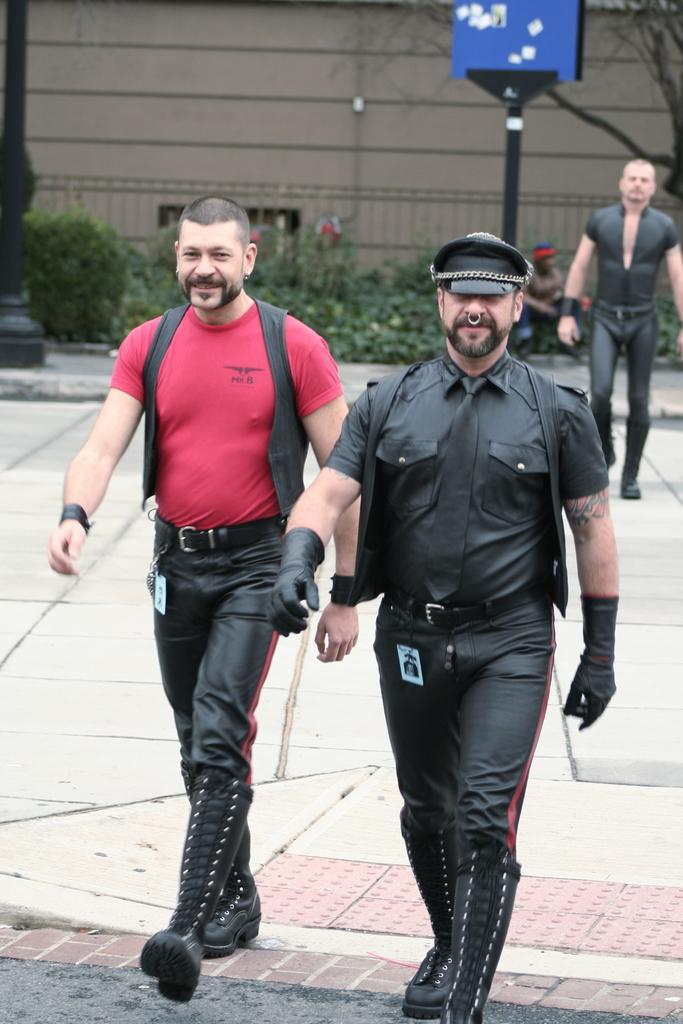Could you give a brief overview of what you see in this image? In this image there are two peoples walking on the path, behind them there is another person. In the background there is a pole, trees, plants, another pole with a board on it and a wall. 